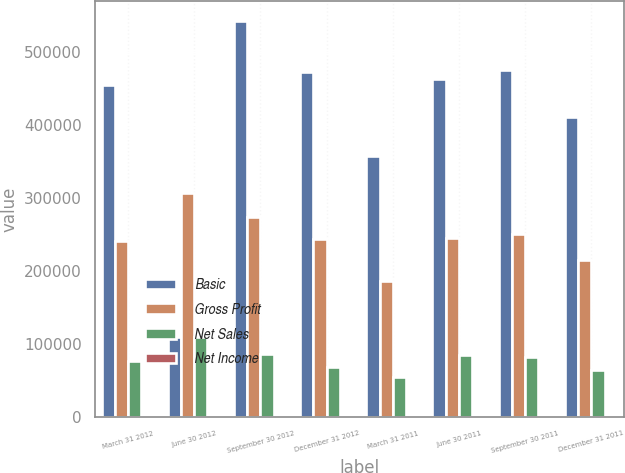<chart> <loc_0><loc_0><loc_500><loc_500><stacked_bar_chart><ecel><fcel>March 31 2012<fcel>June 30 2012<fcel>September 30 2012<fcel>December 31 2012<fcel>March 31 2011<fcel>June 30 2011<fcel>September 30 2011<fcel>December 31 2011<nl><fcel>Basic<fcel>454605<fcel>109795<fcel>541940<fcel>471517<fcel>356419<fcel>462145<fcel>474709<fcel>409957<nl><fcel>Gross Profit<fcel>241169<fcel>307008<fcel>273592<fcel>243887<fcel>185537<fcel>244221<fcel>250307<fcel>214244<nl><fcel>Net Sales<fcel>76099<fcel>109795<fcel>86142<fcel>67984<fcel>55043<fcel>84248<fcel>82392<fcel>64536<nl><fcel>Net Income<fcel>0.44<fcel>0.62<fcel>0.49<fcel>0.4<fcel>0.31<fcel>0.48<fcel>0.47<fcel>0.37<nl></chart> 